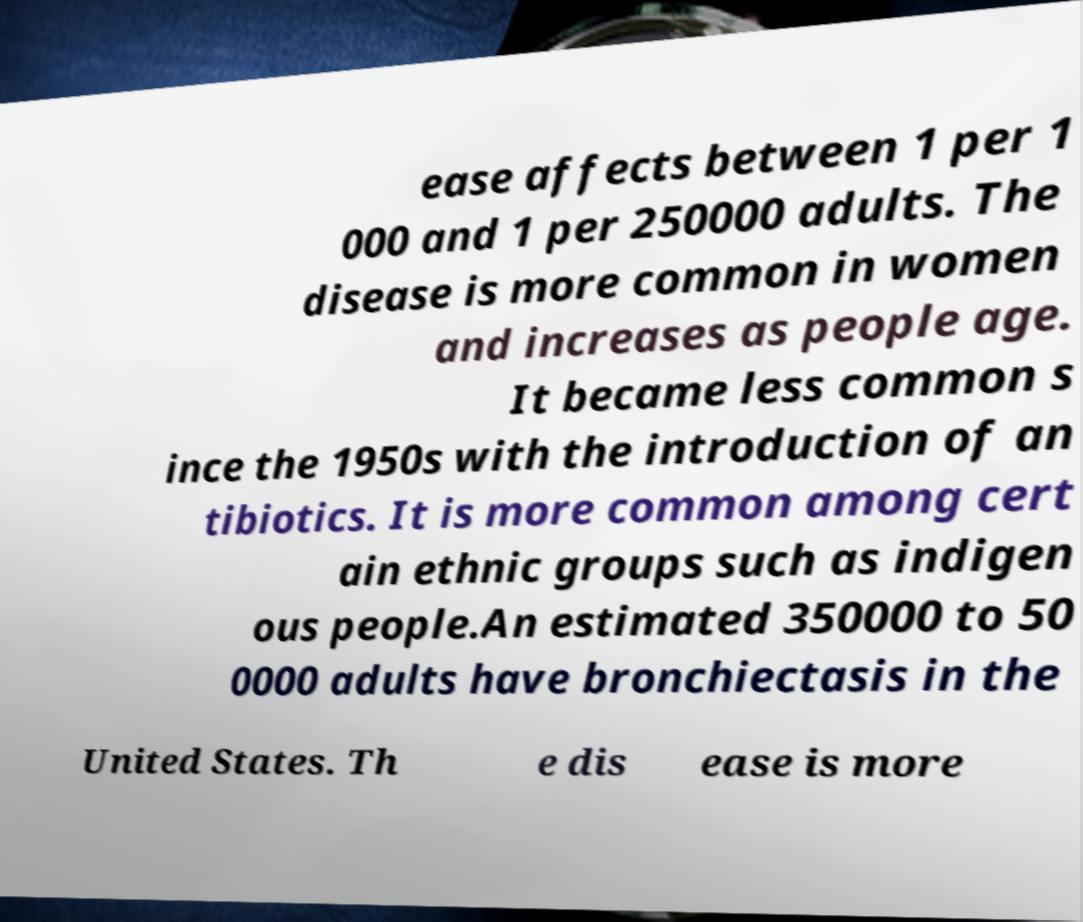Can you read and provide the text displayed in the image?This photo seems to have some interesting text. Can you extract and type it out for me? ease affects between 1 per 1 000 and 1 per 250000 adults. The disease is more common in women and increases as people age. It became less common s ince the 1950s with the introduction of an tibiotics. It is more common among cert ain ethnic groups such as indigen ous people.An estimated 350000 to 50 0000 adults have bronchiectasis in the United States. Th e dis ease is more 